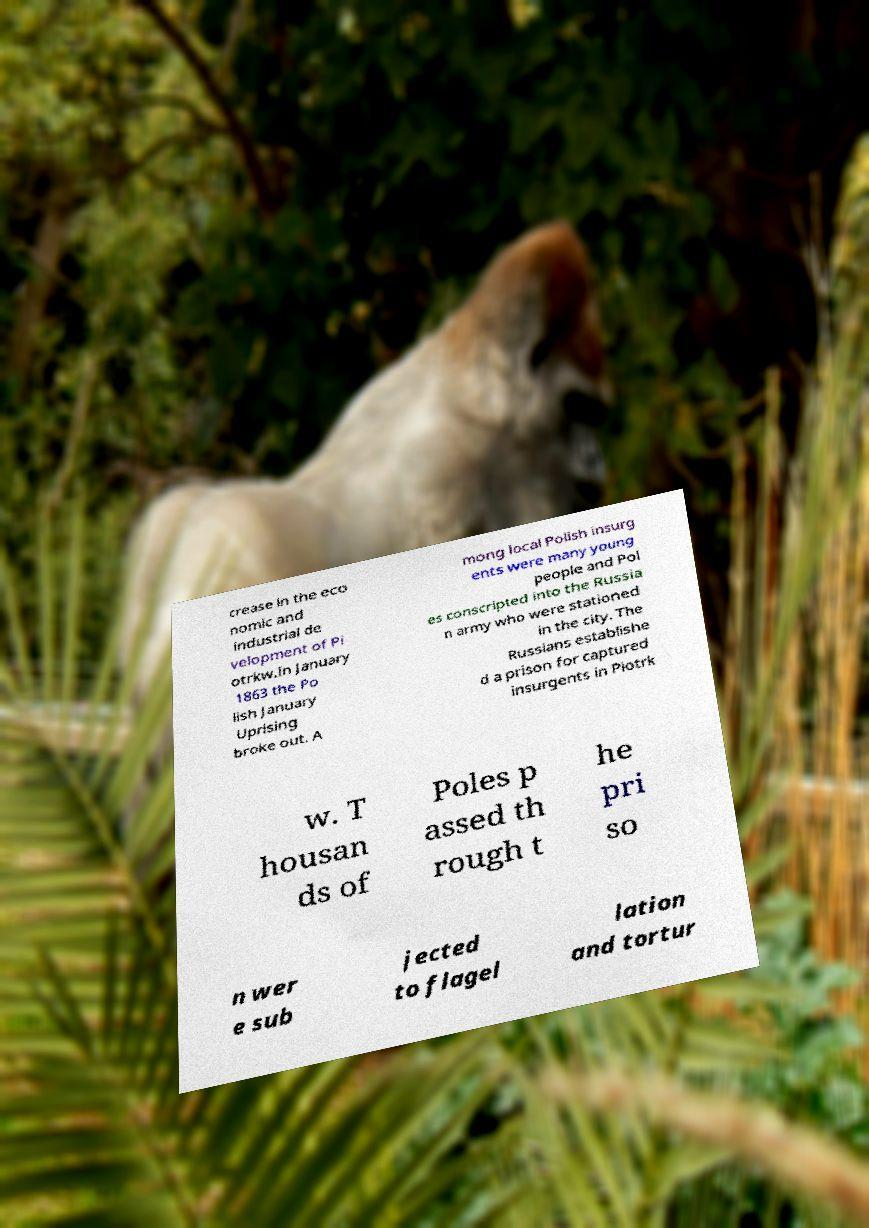I need the written content from this picture converted into text. Can you do that? crease in the eco nomic and industrial de velopment of Pi otrkw.In January 1863 the Po lish January Uprising broke out. A mong local Polish insurg ents were many young people and Pol es conscripted into the Russia n army who were stationed in the city. The Russians establishe d a prison for captured insurgents in Piotrk w. T housan ds of Poles p assed th rough t he pri so n wer e sub jected to flagel lation and tortur 